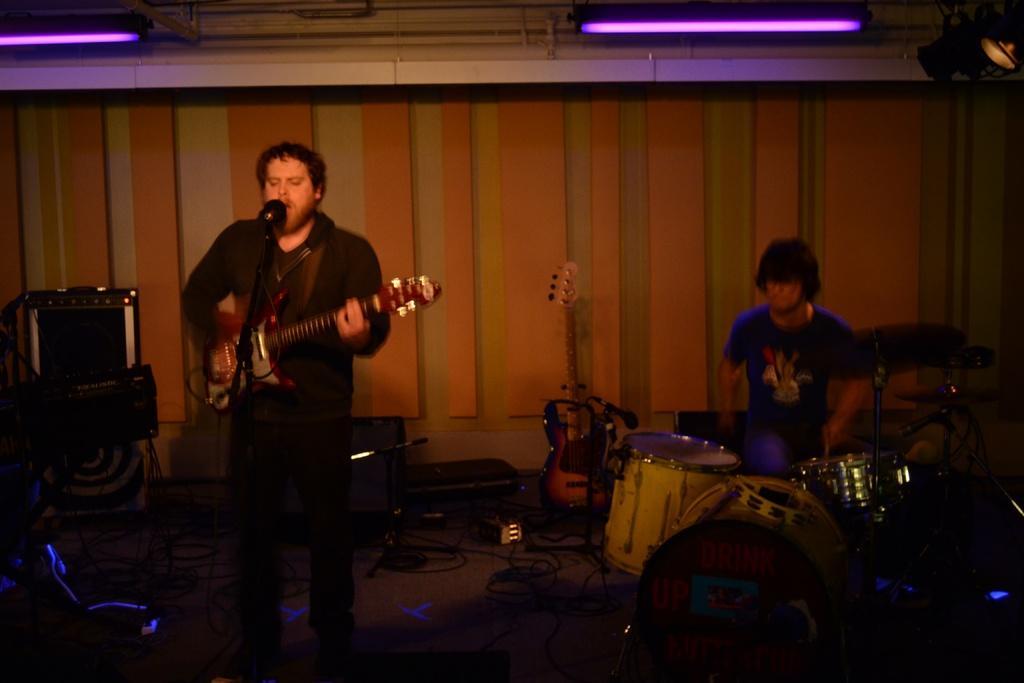How would you summarize this image in a sentence or two? This picture is clicked in musical concern. Man in black t-shirt is holding guitar in his hands and he is playing it and he is even singing on microphone. Beside him, man in blue t-shirt is playing drums. Behind them, we see a wall which is in pink and cream color. On the left corner of the picture, we see television which is placed on table. 